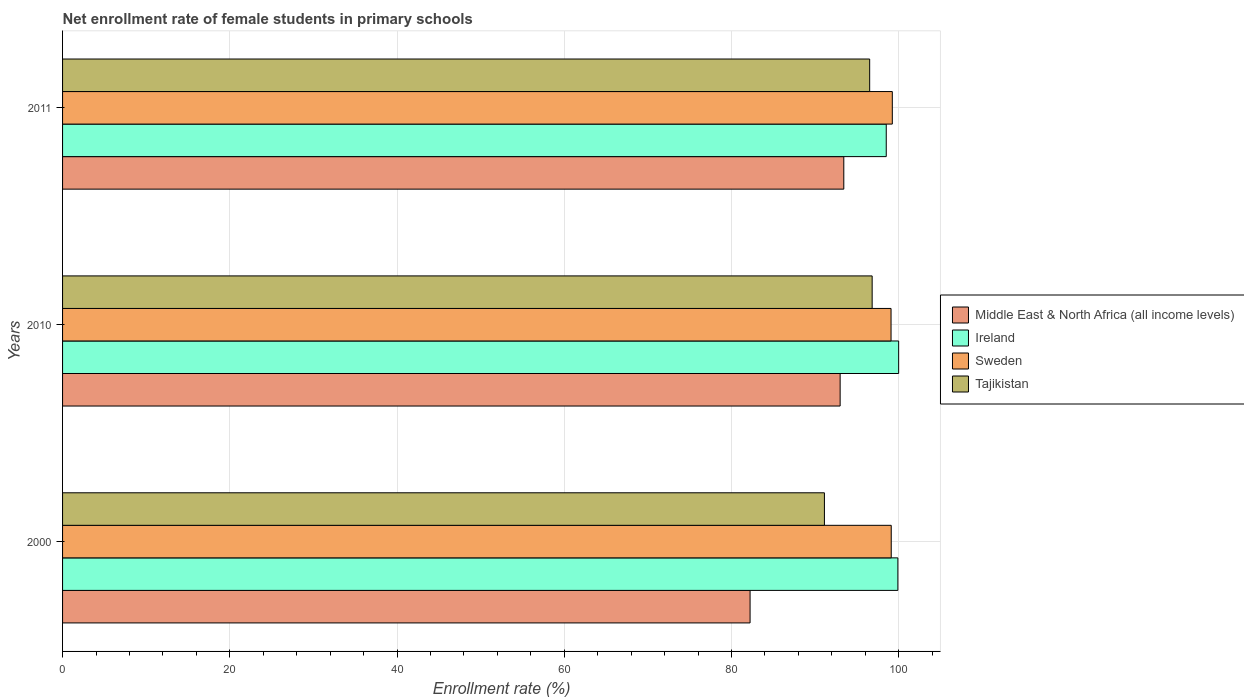How many different coloured bars are there?
Your response must be concise. 4. Are the number of bars per tick equal to the number of legend labels?
Keep it short and to the point. Yes. Are the number of bars on each tick of the Y-axis equal?
Offer a very short reply. Yes. What is the label of the 3rd group of bars from the top?
Offer a very short reply. 2000. What is the net enrollment rate of female students in primary schools in Ireland in 2010?
Give a very brief answer. 99.99. Across all years, what is the maximum net enrollment rate of female students in primary schools in Middle East & North Africa (all income levels)?
Give a very brief answer. 93.43. Across all years, what is the minimum net enrollment rate of female students in primary schools in Middle East & North Africa (all income levels)?
Your answer should be compact. 82.22. In which year was the net enrollment rate of female students in primary schools in Tajikistan maximum?
Provide a short and direct response. 2010. In which year was the net enrollment rate of female students in primary schools in Sweden minimum?
Your answer should be compact. 2010. What is the total net enrollment rate of female students in primary schools in Tajikistan in the graph?
Offer a terse response. 284.46. What is the difference between the net enrollment rate of female students in primary schools in Tajikistan in 2000 and that in 2011?
Offer a terse response. -5.41. What is the difference between the net enrollment rate of female students in primary schools in Tajikistan in 2010 and the net enrollment rate of female students in primary schools in Middle East & North Africa (all income levels) in 2011?
Your answer should be compact. 3.39. What is the average net enrollment rate of female students in primary schools in Middle East & North Africa (all income levels) per year?
Ensure brevity in your answer.  89.55. In the year 2010, what is the difference between the net enrollment rate of female students in primary schools in Tajikistan and net enrollment rate of female students in primary schools in Ireland?
Ensure brevity in your answer.  -3.17. In how many years, is the net enrollment rate of female students in primary schools in Middle East & North Africa (all income levels) greater than 20 %?
Your response must be concise. 3. What is the ratio of the net enrollment rate of female students in primary schools in Middle East & North Africa (all income levels) in 2000 to that in 2010?
Give a very brief answer. 0.88. Is the net enrollment rate of female students in primary schools in Tajikistan in 2000 less than that in 2011?
Your response must be concise. Yes. What is the difference between the highest and the second highest net enrollment rate of female students in primary schools in Sweden?
Offer a terse response. 0.13. What is the difference between the highest and the lowest net enrollment rate of female students in primary schools in Sweden?
Keep it short and to the point. 0.15. In how many years, is the net enrollment rate of female students in primary schools in Sweden greater than the average net enrollment rate of female students in primary schools in Sweden taken over all years?
Ensure brevity in your answer.  1. Is it the case that in every year, the sum of the net enrollment rate of female students in primary schools in Ireland and net enrollment rate of female students in primary schools in Sweden is greater than the sum of net enrollment rate of female students in primary schools in Tajikistan and net enrollment rate of female students in primary schools in Middle East & North Africa (all income levels)?
Provide a short and direct response. No. What does the 3rd bar from the top in 2000 represents?
Keep it short and to the point. Ireland. Is it the case that in every year, the sum of the net enrollment rate of female students in primary schools in Sweden and net enrollment rate of female students in primary schools in Middle East & North Africa (all income levels) is greater than the net enrollment rate of female students in primary schools in Ireland?
Your response must be concise. Yes. How many years are there in the graph?
Keep it short and to the point. 3. What is the difference between two consecutive major ticks on the X-axis?
Your answer should be very brief. 20. Does the graph contain grids?
Provide a short and direct response. Yes. How are the legend labels stacked?
Provide a short and direct response. Vertical. What is the title of the graph?
Offer a very short reply. Net enrollment rate of female students in primary schools. Does "Liberia" appear as one of the legend labels in the graph?
Ensure brevity in your answer.  No. What is the label or title of the X-axis?
Ensure brevity in your answer.  Enrollment rate (%). What is the label or title of the Y-axis?
Provide a short and direct response. Years. What is the Enrollment rate (%) of Middle East & North Africa (all income levels) in 2000?
Make the answer very short. 82.22. What is the Enrollment rate (%) in Ireland in 2000?
Give a very brief answer. 99.9. What is the Enrollment rate (%) of Sweden in 2000?
Provide a short and direct response. 99.1. What is the Enrollment rate (%) of Tajikistan in 2000?
Offer a very short reply. 91.11. What is the Enrollment rate (%) of Middle East & North Africa (all income levels) in 2010?
Provide a succinct answer. 92.99. What is the Enrollment rate (%) of Ireland in 2010?
Your answer should be compact. 99.99. What is the Enrollment rate (%) of Sweden in 2010?
Provide a short and direct response. 99.08. What is the Enrollment rate (%) of Tajikistan in 2010?
Offer a very short reply. 96.82. What is the Enrollment rate (%) in Middle East & North Africa (all income levels) in 2011?
Give a very brief answer. 93.43. What is the Enrollment rate (%) in Ireland in 2011?
Offer a terse response. 98.51. What is the Enrollment rate (%) of Sweden in 2011?
Your answer should be compact. 99.23. What is the Enrollment rate (%) of Tajikistan in 2011?
Give a very brief answer. 96.52. Across all years, what is the maximum Enrollment rate (%) of Middle East & North Africa (all income levels)?
Your answer should be compact. 93.43. Across all years, what is the maximum Enrollment rate (%) in Ireland?
Offer a very short reply. 99.99. Across all years, what is the maximum Enrollment rate (%) of Sweden?
Give a very brief answer. 99.23. Across all years, what is the maximum Enrollment rate (%) in Tajikistan?
Your answer should be compact. 96.82. Across all years, what is the minimum Enrollment rate (%) of Middle East & North Africa (all income levels)?
Offer a very short reply. 82.22. Across all years, what is the minimum Enrollment rate (%) of Ireland?
Keep it short and to the point. 98.51. Across all years, what is the minimum Enrollment rate (%) in Sweden?
Your response must be concise. 99.08. Across all years, what is the minimum Enrollment rate (%) in Tajikistan?
Provide a succinct answer. 91.11. What is the total Enrollment rate (%) in Middle East & North Africa (all income levels) in the graph?
Offer a very short reply. 268.64. What is the total Enrollment rate (%) in Ireland in the graph?
Your response must be concise. 298.39. What is the total Enrollment rate (%) of Sweden in the graph?
Your response must be concise. 297.41. What is the total Enrollment rate (%) in Tajikistan in the graph?
Ensure brevity in your answer.  284.46. What is the difference between the Enrollment rate (%) of Middle East & North Africa (all income levels) in 2000 and that in 2010?
Provide a short and direct response. -10.77. What is the difference between the Enrollment rate (%) in Ireland in 2000 and that in 2010?
Your response must be concise. -0.09. What is the difference between the Enrollment rate (%) of Sweden in 2000 and that in 2010?
Offer a very short reply. 0.02. What is the difference between the Enrollment rate (%) of Tajikistan in 2000 and that in 2010?
Offer a terse response. -5.71. What is the difference between the Enrollment rate (%) of Middle East & North Africa (all income levels) in 2000 and that in 2011?
Your answer should be compact. -11.21. What is the difference between the Enrollment rate (%) of Ireland in 2000 and that in 2011?
Give a very brief answer. 1.39. What is the difference between the Enrollment rate (%) in Sweden in 2000 and that in 2011?
Your answer should be compact. -0.13. What is the difference between the Enrollment rate (%) in Tajikistan in 2000 and that in 2011?
Ensure brevity in your answer.  -5.41. What is the difference between the Enrollment rate (%) of Middle East & North Africa (all income levels) in 2010 and that in 2011?
Offer a terse response. -0.44. What is the difference between the Enrollment rate (%) in Ireland in 2010 and that in 2011?
Your answer should be compact. 1.48. What is the difference between the Enrollment rate (%) of Sweden in 2010 and that in 2011?
Your answer should be compact. -0.15. What is the difference between the Enrollment rate (%) in Tajikistan in 2010 and that in 2011?
Ensure brevity in your answer.  0.3. What is the difference between the Enrollment rate (%) in Middle East & North Africa (all income levels) in 2000 and the Enrollment rate (%) in Ireland in 2010?
Give a very brief answer. -17.77. What is the difference between the Enrollment rate (%) in Middle East & North Africa (all income levels) in 2000 and the Enrollment rate (%) in Sweden in 2010?
Your answer should be very brief. -16.86. What is the difference between the Enrollment rate (%) of Middle East & North Africa (all income levels) in 2000 and the Enrollment rate (%) of Tajikistan in 2010?
Make the answer very short. -14.6. What is the difference between the Enrollment rate (%) of Ireland in 2000 and the Enrollment rate (%) of Sweden in 2010?
Provide a short and direct response. 0.82. What is the difference between the Enrollment rate (%) of Ireland in 2000 and the Enrollment rate (%) of Tajikistan in 2010?
Your response must be concise. 3.08. What is the difference between the Enrollment rate (%) in Sweden in 2000 and the Enrollment rate (%) in Tajikistan in 2010?
Ensure brevity in your answer.  2.28. What is the difference between the Enrollment rate (%) of Middle East & North Africa (all income levels) in 2000 and the Enrollment rate (%) of Ireland in 2011?
Ensure brevity in your answer.  -16.28. What is the difference between the Enrollment rate (%) in Middle East & North Africa (all income levels) in 2000 and the Enrollment rate (%) in Sweden in 2011?
Your answer should be compact. -17.01. What is the difference between the Enrollment rate (%) in Middle East & North Africa (all income levels) in 2000 and the Enrollment rate (%) in Tajikistan in 2011?
Provide a short and direct response. -14.3. What is the difference between the Enrollment rate (%) of Ireland in 2000 and the Enrollment rate (%) of Sweden in 2011?
Ensure brevity in your answer.  0.67. What is the difference between the Enrollment rate (%) of Ireland in 2000 and the Enrollment rate (%) of Tajikistan in 2011?
Keep it short and to the point. 3.37. What is the difference between the Enrollment rate (%) in Sweden in 2000 and the Enrollment rate (%) in Tajikistan in 2011?
Provide a short and direct response. 2.58. What is the difference between the Enrollment rate (%) of Middle East & North Africa (all income levels) in 2010 and the Enrollment rate (%) of Ireland in 2011?
Provide a succinct answer. -5.51. What is the difference between the Enrollment rate (%) of Middle East & North Africa (all income levels) in 2010 and the Enrollment rate (%) of Sweden in 2011?
Make the answer very short. -6.24. What is the difference between the Enrollment rate (%) of Middle East & North Africa (all income levels) in 2010 and the Enrollment rate (%) of Tajikistan in 2011?
Make the answer very short. -3.53. What is the difference between the Enrollment rate (%) in Ireland in 2010 and the Enrollment rate (%) in Sweden in 2011?
Offer a very short reply. 0.76. What is the difference between the Enrollment rate (%) of Ireland in 2010 and the Enrollment rate (%) of Tajikistan in 2011?
Provide a short and direct response. 3.47. What is the difference between the Enrollment rate (%) of Sweden in 2010 and the Enrollment rate (%) of Tajikistan in 2011?
Offer a very short reply. 2.56. What is the average Enrollment rate (%) in Middle East & North Africa (all income levels) per year?
Offer a terse response. 89.55. What is the average Enrollment rate (%) of Ireland per year?
Your answer should be very brief. 99.46. What is the average Enrollment rate (%) of Sweden per year?
Provide a short and direct response. 99.14. What is the average Enrollment rate (%) of Tajikistan per year?
Your response must be concise. 94.82. In the year 2000, what is the difference between the Enrollment rate (%) of Middle East & North Africa (all income levels) and Enrollment rate (%) of Ireland?
Offer a terse response. -17.68. In the year 2000, what is the difference between the Enrollment rate (%) of Middle East & North Africa (all income levels) and Enrollment rate (%) of Sweden?
Provide a short and direct response. -16.88. In the year 2000, what is the difference between the Enrollment rate (%) of Middle East & North Africa (all income levels) and Enrollment rate (%) of Tajikistan?
Ensure brevity in your answer.  -8.89. In the year 2000, what is the difference between the Enrollment rate (%) of Ireland and Enrollment rate (%) of Sweden?
Your answer should be very brief. 0.79. In the year 2000, what is the difference between the Enrollment rate (%) in Ireland and Enrollment rate (%) in Tajikistan?
Your answer should be compact. 8.78. In the year 2000, what is the difference between the Enrollment rate (%) in Sweden and Enrollment rate (%) in Tajikistan?
Ensure brevity in your answer.  7.99. In the year 2010, what is the difference between the Enrollment rate (%) in Middle East & North Africa (all income levels) and Enrollment rate (%) in Ireland?
Your response must be concise. -7. In the year 2010, what is the difference between the Enrollment rate (%) in Middle East & North Africa (all income levels) and Enrollment rate (%) in Sweden?
Make the answer very short. -6.09. In the year 2010, what is the difference between the Enrollment rate (%) in Middle East & North Africa (all income levels) and Enrollment rate (%) in Tajikistan?
Your answer should be compact. -3.83. In the year 2010, what is the difference between the Enrollment rate (%) of Ireland and Enrollment rate (%) of Sweden?
Provide a succinct answer. 0.91. In the year 2010, what is the difference between the Enrollment rate (%) in Ireland and Enrollment rate (%) in Tajikistan?
Provide a succinct answer. 3.17. In the year 2010, what is the difference between the Enrollment rate (%) in Sweden and Enrollment rate (%) in Tajikistan?
Offer a terse response. 2.26. In the year 2011, what is the difference between the Enrollment rate (%) in Middle East & North Africa (all income levels) and Enrollment rate (%) in Ireland?
Ensure brevity in your answer.  -5.08. In the year 2011, what is the difference between the Enrollment rate (%) of Middle East & North Africa (all income levels) and Enrollment rate (%) of Sweden?
Provide a succinct answer. -5.8. In the year 2011, what is the difference between the Enrollment rate (%) in Middle East & North Africa (all income levels) and Enrollment rate (%) in Tajikistan?
Provide a succinct answer. -3.09. In the year 2011, what is the difference between the Enrollment rate (%) in Ireland and Enrollment rate (%) in Sweden?
Give a very brief answer. -0.73. In the year 2011, what is the difference between the Enrollment rate (%) in Ireland and Enrollment rate (%) in Tajikistan?
Keep it short and to the point. 1.98. In the year 2011, what is the difference between the Enrollment rate (%) of Sweden and Enrollment rate (%) of Tajikistan?
Ensure brevity in your answer.  2.71. What is the ratio of the Enrollment rate (%) in Middle East & North Africa (all income levels) in 2000 to that in 2010?
Your answer should be very brief. 0.88. What is the ratio of the Enrollment rate (%) in Ireland in 2000 to that in 2010?
Offer a terse response. 1. What is the ratio of the Enrollment rate (%) of Sweden in 2000 to that in 2010?
Provide a short and direct response. 1. What is the ratio of the Enrollment rate (%) in Tajikistan in 2000 to that in 2010?
Your response must be concise. 0.94. What is the ratio of the Enrollment rate (%) in Middle East & North Africa (all income levels) in 2000 to that in 2011?
Your response must be concise. 0.88. What is the ratio of the Enrollment rate (%) in Ireland in 2000 to that in 2011?
Keep it short and to the point. 1.01. What is the ratio of the Enrollment rate (%) of Tajikistan in 2000 to that in 2011?
Offer a terse response. 0.94. What is the ratio of the Enrollment rate (%) in Middle East & North Africa (all income levels) in 2010 to that in 2011?
Provide a short and direct response. 1. What is the ratio of the Enrollment rate (%) in Ireland in 2010 to that in 2011?
Keep it short and to the point. 1.02. What is the difference between the highest and the second highest Enrollment rate (%) in Middle East & North Africa (all income levels)?
Your answer should be very brief. 0.44. What is the difference between the highest and the second highest Enrollment rate (%) of Ireland?
Your answer should be very brief. 0.09. What is the difference between the highest and the second highest Enrollment rate (%) of Sweden?
Keep it short and to the point. 0.13. What is the difference between the highest and the second highest Enrollment rate (%) of Tajikistan?
Provide a succinct answer. 0.3. What is the difference between the highest and the lowest Enrollment rate (%) in Middle East & North Africa (all income levels)?
Your answer should be compact. 11.21. What is the difference between the highest and the lowest Enrollment rate (%) in Ireland?
Give a very brief answer. 1.48. What is the difference between the highest and the lowest Enrollment rate (%) of Sweden?
Provide a succinct answer. 0.15. What is the difference between the highest and the lowest Enrollment rate (%) of Tajikistan?
Your answer should be very brief. 5.71. 